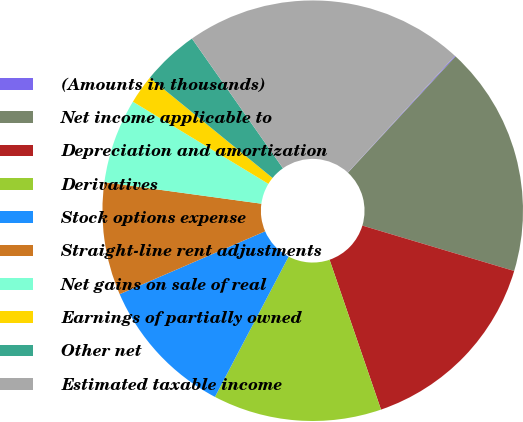Convert chart. <chart><loc_0><loc_0><loc_500><loc_500><pie_chart><fcel>(Amounts in thousands)<fcel>Net income applicable to<fcel>Depreciation and amortization<fcel>Derivatives<fcel>Stock options expense<fcel>Straight-line rent adjustments<fcel>Net gains on sale of real<fcel>Earnings of partially owned<fcel>Other net<fcel>Estimated taxable income<nl><fcel>0.07%<fcel>17.74%<fcel>15.11%<fcel>12.96%<fcel>10.81%<fcel>8.66%<fcel>6.51%<fcel>2.22%<fcel>4.37%<fcel>21.55%<nl></chart> 